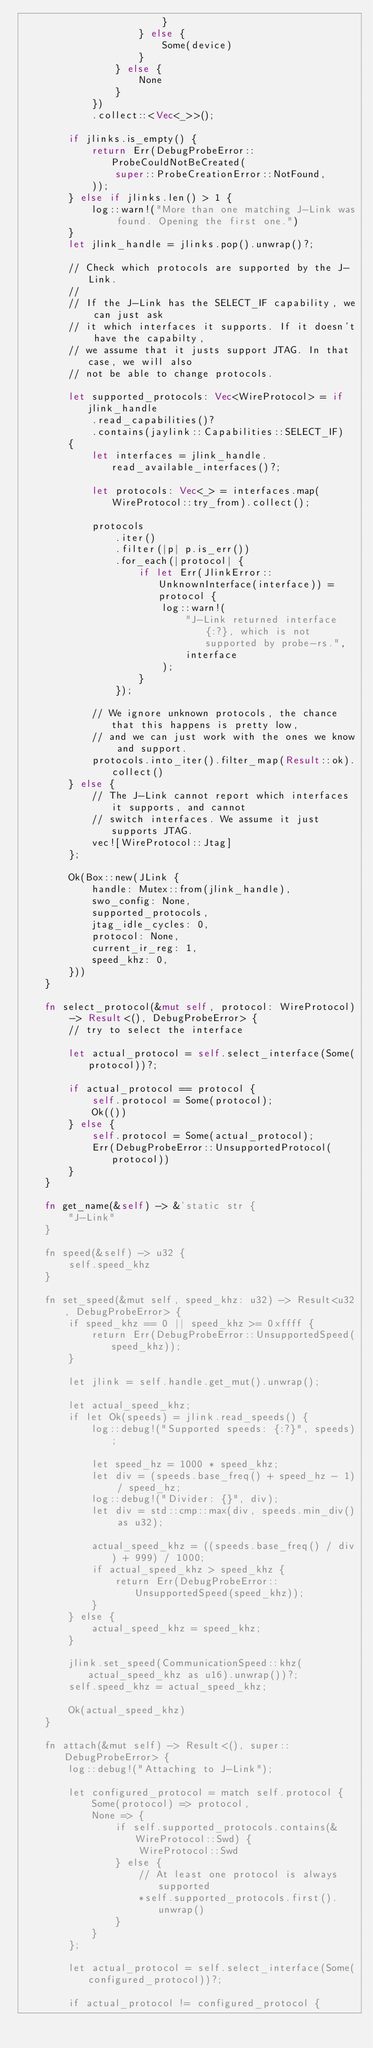<code> <loc_0><loc_0><loc_500><loc_500><_Rust_>                        }
                    } else {
                        Some(device)
                    }
                } else {
                    None
                }
            })
            .collect::<Vec<_>>();

        if jlinks.is_empty() {
            return Err(DebugProbeError::ProbeCouldNotBeCreated(
                super::ProbeCreationError::NotFound,
            ));
        } else if jlinks.len() > 1 {
            log::warn!("More than one matching J-Link was found. Opening the first one.")
        }
        let jlink_handle = jlinks.pop().unwrap()?;

        // Check which protocols are supported by the J-Link.
        //
        // If the J-Link has the SELECT_IF capability, we can just ask
        // it which interfaces it supports. If it doesn't have the capabilty,
        // we assume that it justs support JTAG. In that case, we will also
        // not be able to change protocols.

        let supported_protocols: Vec<WireProtocol> = if jlink_handle
            .read_capabilities()?
            .contains(jaylink::Capabilities::SELECT_IF)
        {
            let interfaces = jlink_handle.read_available_interfaces()?;

            let protocols: Vec<_> = interfaces.map(WireProtocol::try_from).collect();

            protocols
                .iter()
                .filter(|p| p.is_err())
                .for_each(|protocol| {
                    if let Err(JlinkError::UnknownInterface(interface)) = protocol {
                        log::warn!(
                            "J-Link returned interface {:?}, which is not supported by probe-rs.",
                            interface
                        );
                    }
                });

            // We ignore unknown protocols, the chance that this happens is pretty low,
            // and we can just work with the ones we know and support.
            protocols.into_iter().filter_map(Result::ok).collect()
        } else {
            // The J-Link cannot report which interfaces it supports, and cannot
            // switch interfaces. We assume it just supports JTAG.
            vec![WireProtocol::Jtag]
        };

        Ok(Box::new(JLink {
            handle: Mutex::from(jlink_handle),
            swo_config: None,
            supported_protocols,
            jtag_idle_cycles: 0,
            protocol: None,
            current_ir_reg: 1,
            speed_khz: 0,
        }))
    }

    fn select_protocol(&mut self, protocol: WireProtocol) -> Result<(), DebugProbeError> {
        // try to select the interface

        let actual_protocol = self.select_interface(Some(protocol))?;

        if actual_protocol == protocol {
            self.protocol = Some(protocol);
            Ok(())
        } else {
            self.protocol = Some(actual_protocol);
            Err(DebugProbeError::UnsupportedProtocol(protocol))
        }
    }

    fn get_name(&self) -> &'static str {
        "J-Link"
    }

    fn speed(&self) -> u32 {
        self.speed_khz
    }

    fn set_speed(&mut self, speed_khz: u32) -> Result<u32, DebugProbeError> {
        if speed_khz == 0 || speed_khz >= 0xffff {
            return Err(DebugProbeError::UnsupportedSpeed(speed_khz));
        }

        let jlink = self.handle.get_mut().unwrap();

        let actual_speed_khz;
        if let Ok(speeds) = jlink.read_speeds() {
            log::debug!("Supported speeds: {:?}", speeds);

            let speed_hz = 1000 * speed_khz;
            let div = (speeds.base_freq() + speed_hz - 1) / speed_hz;
            log::debug!("Divider: {}", div);
            let div = std::cmp::max(div, speeds.min_div() as u32);

            actual_speed_khz = ((speeds.base_freq() / div) + 999) / 1000;
            if actual_speed_khz > speed_khz {
                return Err(DebugProbeError::UnsupportedSpeed(speed_khz));
            }
        } else {
            actual_speed_khz = speed_khz;
        }

        jlink.set_speed(CommunicationSpeed::khz(actual_speed_khz as u16).unwrap())?;
        self.speed_khz = actual_speed_khz;

        Ok(actual_speed_khz)
    }

    fn attach(&mut self) -> Result<(), super::DebugProbeError> {
        log::debug!("Attaching to J-Link");

        let configured_protocol = match self.protocol {
            Some(protocol) => protocol,
            None => {
                if self.supported_protocols.contains(&WireProtocol::Swd) {
                    WireProtocol::Swd
                } else {
                    // At least one protocol is always supported
                    *self.supported_protocols.first().unwrap()
                }
            }
        };

        let actual_protocol = self.select_interface(Some(configured_protocol))?;

        if actual_protocol != configured_protocol {</code> 